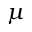<formula> <loc_0><loc_0><loc_500><loc_500>\mu</formula> 